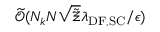Convert formula to latex. <formula><loc_0><loc_0><loc_500><loc_500>\widetilde { \mathcal { O } } ( N _ { k } N \sqrt { \tilde { \Xi } } \lambda _ { D F , S C } / \epsilon )</formula> 